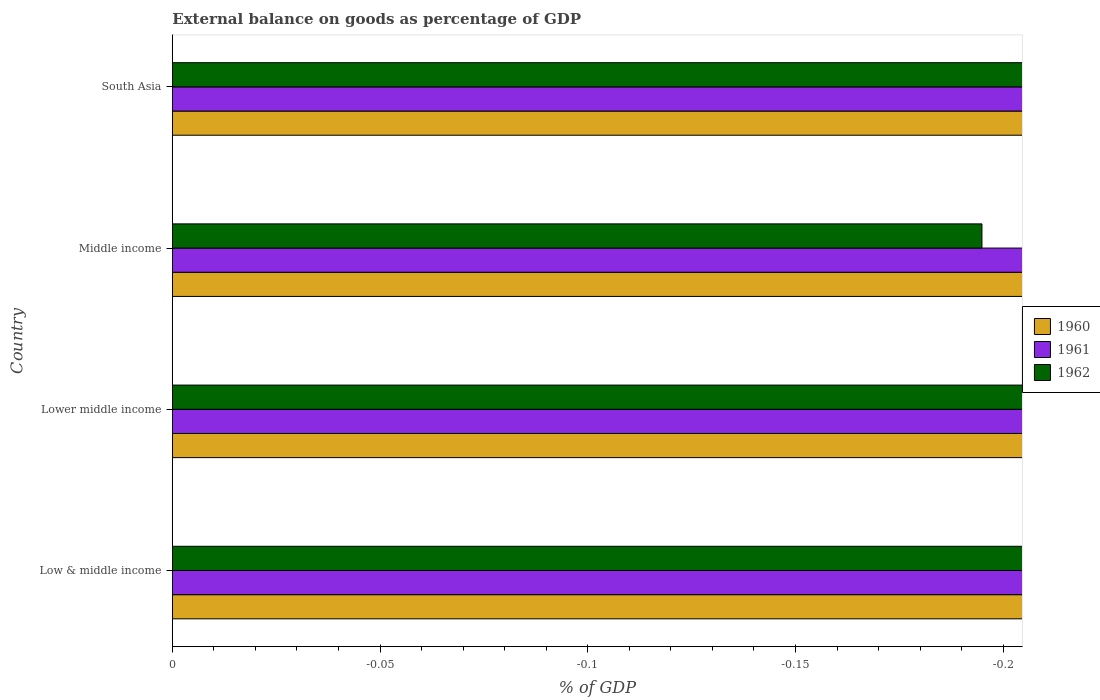How many different coloured bars are there?
Provide a succinct answer. 0. Are the number of bars on each tick of the Y-axis equal?
Keep it short and to the point. Yes. What is the label of the 2nd group of bars from the top?
Your answer should be compact. Middle income. What is the external balance on goods as percentage of GDP in 1960 in South Asia?
Your answer should be very brief. 0. Across all countries, what is the minimum external balance on goods as percentage of GDP in 1961?
Offer a terse response. 0. What is the total external balance on goods as percentage of GDP in 1962 in the graph?
Provide a succinct answer. 0. What is the difference between the external balance on goods as percentage of GDP in 1961 in South Asia and the external balance on goods as percentage of GDP in 1960 in Low & middle income?
Provide a short and direct response. 0. What is the average external balance on goods as percentage of GDP in 1962 per country?
Provide a short and direct response. 0. In how many countries, is the external balance on goods as percentage of GDP in 1960 greater than -0.09000000000000001 %?
Your answer should be compact. 0. In how many countries, is the external balance on goods as percentage of GDP in 1962 greater than the average external balance on goods as percentage of GDP in 1962 taken over all countries?
Your answer should be compact. 0. Are all the bars in the graph horizontal?
Give a very brief answer. Yes. What is the difference between two consecutive major ticks on the X-axis?
Ensure brevity in your answer.  0.05. What is the title of the graph?
Your answer should be compact. External balance on goods as percentage of GDP. Does "1969" appear as one of the legend labels in the graph?
Your response must be concise. No. What is the label or title of the X-axis?
Make the answer very short. % of GDP. What is the label or title of the Y-axis?
Keep it short and to the point. Country. What is the % of GDP of 1960 in Lower middle income?
Make the answer very short. 0. What is the % of GDP in 1961 in Lower middle income?
Keep it short and to the point. 0. What is the % of GDP in 1960 in Middle income?
Keep it short and to the point. 0. What is the % of GDP in 1960 in South Asia?
Provide a succinct answer. 0. What is the % of GDP in 1962 in South Asia?
Your answer should be very brief. 0. What is the total % of GDP of 1960 in the graph?
Ensure brevity in your answer.  0. What is the total % of GDP in 1961 in the graph?
Offer a terse response. 0. What is the total % of GDP of 1962 in the graph?
Your response must be concise. 0. What is the average % of GDP in 1960 per country?
Keep it short and to the point. 0. 